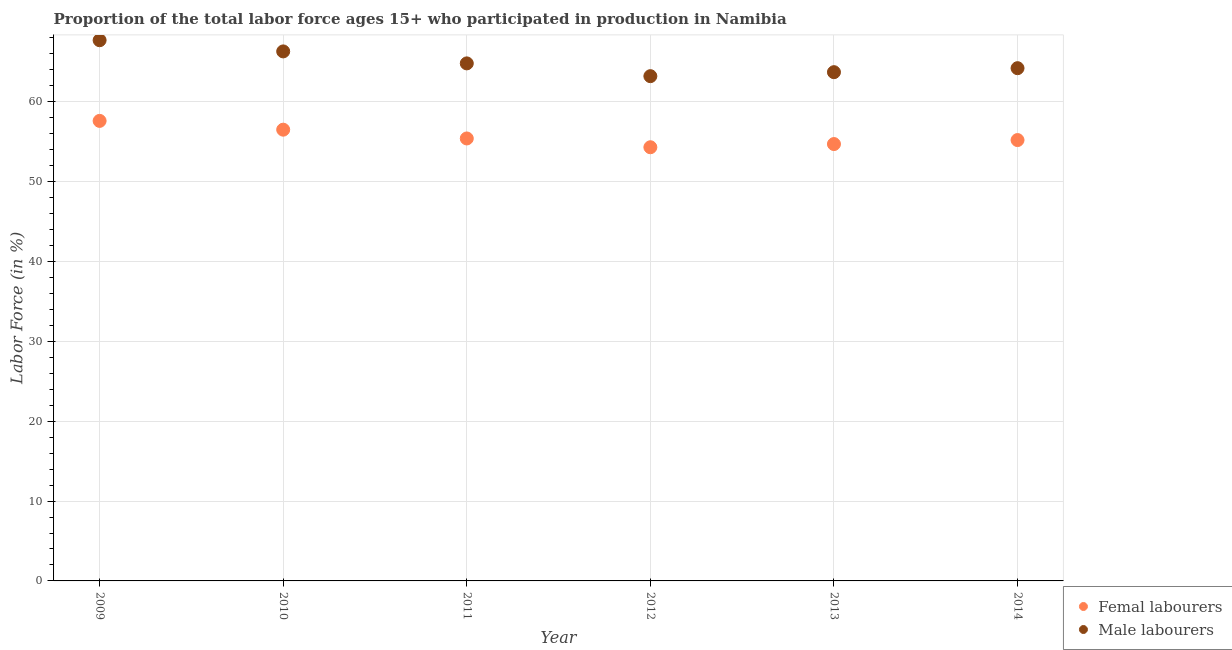How many different coloured dotlines are there?
Offer a terse response. 2. Is the number of dotlines equal to the number of legend labels?
Provide a succinct answer. Yes. What is the percentage of male labour force in 2011?
Keep it short and to the point. 64.8. Across all years, what is the maximum percentage of male labour force?
Your response must be concise. 67.7. Across all years, what is the minimum percentage of male labour force?
Provide a succinct answer. 63.2. In which year was the percentage of female labor force maximum?
Provide a short and direct response. 2009. What is the total percentage of female labor force in the graph?
Keep it short and to the point. 333.7. What is the difference between the percentage of female labor force in 2009 and that in 2013?
Ensure brevity in your answer.  2.9. What is the difference between the percentage of male labour force in 2013 and the percentage of female labor force in 2012?
Your response must be concise. 9.4. What is the average percentage of male labour force per year?
Provide a short and direct response. 64.98. In the year 2011, what is the difference between the percentage of female labor force and percentage of male labour force?
Your response must be concise. -9.4. What is the ratio of the percentage of male labour force in 2009 to that in 2013?
Keep it short and to the point. 1.06. What is the difference between the highest and the second highest percentage of male labour force?
Provide a short and direct response. 1.4. What is the difference between the highest and the lowest percentage of female labor force?
Your answer should be compact. 3.3. In how many years, is the percentage of female labor force greater than the average percentage of female labor force taken over all years?
Your answer should be compact. 2. Is the percentage of female labor force strictly greater than the percentage of male labour force over the years?
Give a very brief answer. No. How many dotlines are there?
Keep it short and to the point. 2. How many years are there in the graph?
Your response must be concise. 6. What is the difference between two consecutive major ticks on the Y-axis?
Give a very brief answer. 10. Are the values on the major ticks of Y-axis written in scientific E-notation?
Provide a succinct answer. No. Where does the legend appear in the graph?
Give a very brief answer. Bottom right. How many legend labels are there?
Make the answer very short. 2. How are the legend labels stacked?
Your answer should be compact. Vertical. What is the title of the graph?
Your response must be concise. Proportion of the total labor force ages 15+ who participated in production in Namibia. What is the Labor Force (in %) of Femal labourers in 2009?
Your answer should be compact. 57.6. What is the Labor Force (in %) in Male labourers in 2009?
Provide a short and direct response. 67.7. What is the Labor Force (in %) in Femal labourers in 2010?
Make the answer very short. 56.5. What is the Labor Force (in %) in Male labourers in 2010?
Your answer should be compact. 66.3. What is the Labor Force (in %) of Femal labourers in 2011?
Provide a succinct answer. 55.4. What is the Labor Force (in %) in Male labourers in 2011?
Provide a short and direct response. 64.8. What is the Labor Force (in %) of Femal labourers in 2012?
Provide a short and direct response. 54.3. What is the Labor Force (in %) of Male labourers in 2012?
Keep it short and to the point. 63.2. What is the Labor Force (in %) in Femal labourers in 2013?
Your response must be concise. 54.7. What is the Labor Force (in %) in Male labourers in 2013?
Make the answer very short. 63.7. What is the Labor Force (in %) of Femal labourers in 2014?
Give a very brief answer. 55.2. What is the Labor Force (in %) in Male labourers in 2014?
Give a very brief answer. 64.2. Across all years, what is the maximum Labor Force (in %) in Femal labourers?
Your answer should be compact. 57.6. Across all years, what is the maximum Labor Force (in %) in Male labourers?
Offer a very short reply. 67.7. Across all years, what is the minimum Labor Force (in %) in Femal labourers?
Ensure brevity in your answer.  54.3. Across all years, what is the minimum Labor Force (in %) of Male labourers?
Ensure brevity in your answer.  63.2. What is the total Labor Force (in %) in Femal labourers in the graph?
Offer a very short reply. 333.7. What is the total Labor Force (in %) of Male labourers in the graph?
Offer a very short reply. 389.9. What is the difference between the Labor Force (in %) of Femal labourers in 2009 and that in 2010?
Keep it short and to the point. 1.1. What is the difference between the Labor Force (in %) in Male labourers in 2009 and that in 2010?
Your answer should be compact. 1.4. What is the difference between the Labor Force (in %) in Femal labourers in 2009 and that in 2011?
Your answer should be very brief. 2.2. What is the difference between the Labor Force (in %) in Male labourers in 2009 and that in 2011?
Offer a very short reply. 2.9. What is the difference between the Labor Force (in %) of Femal labourers in 2009 and that in 2012?
Your response must be concise. 3.3. What is the difference between the Labor Force (in %) of Male labourers in 2009 and that in 2013?
Provide a succinct answer. 4. What is the difference between the Labor Force (in %) in Femal labourers in 2010 and that in 2011?
Offer a terse response. 1.1. What is the difference between the Labor Force (in %) in Male labourers in 2010 and that in 2011?
Your response must be concise. 1.5. What is the difference between the Labor Force (in %) in Femal labourers in 2010 and that in 2012?
Give a very brief answer. 2.2. What is the difference between the Labor Force (in %) of Femal labourers in 2010 and that in 2013?
Provide a succinct answer. 1.8. What is the difference between the Labor Force (in %) in Male labourers in 2010 and that in 2013?
Offer a very short reply. 2.6. What is the difference between the Labor Force (in %) in Male labourers in 2010 and that in 2014?
Give a very brief answer. 2.1. What is the difference between the Labor Force (in %) in Femal labourers in 2011 and that in 2012?
Ensure brevity in your answer.  1.1. What is the difference between the Labor Force (in %) of Male labourers in 2012 and that in 2013?
Your answer should be compact. -0.5. What is the difference between the Labor Force (in %) of Male labourers in 2012 and that in 2014?
Provide a short and direct response. -1. What is the difference between the Labor Force (in %) of Male labourers in 2013 and that in 2014?
Offer a terse response. -0.5. What is the difference between the Labor Force (in %) of Femal labourers in 2009 and the Labor Force (in %) of Male labourers in 2011?
Keep it short and to the point. -7.2. What is the difference between the Labor Force (in %) of Femal labourers in 2010 and the Labor Force (in %) of Male labourers in 2011?
Make the answer very short. -8.3. What is the difference between the Labor Force (in %) of Femal labourers in 2010 and the Labor Force (in %) of Male labourers in 2012?
Provide a short and direct response. -6.7. What is the difference between the Labor Force (in %) of Femal labourers in 2010 and the Labor Force (in %) of Male labourers in 2013?
Provide a short and direct response. -7.2. What is the difference between the Labor Force (in %) of Femal labourers in 2010 and the Labor Force (in %) of Male labourers in 2014?
Your response must be concise. -7.7. What is the difference between the Labor Force (in %) in Femal labourers in 2011 and the Labor Force (in %) in Male labourers in 2013?
Provide a succinct answer. -8.3. What is the difference between the Labor Force (in %) in Femal labourers in 2012 and the Labor Force (in %) in Male labourers in 2013?
Offer a terse response. -9.4. What is the average Labor Force (in %) in Femal labourers per year?
Your response must be concise. 55.62. What is the average Labor Force (in %) in Male labourers per year?
Ensure brevity in your answer.  64.98. In the year 2009, what is the difference between the Labor Force (in %) of Femal labourers and Labor Force (in %) of Male labourers?
Provide a succinct answer. -10.1. In the year 2010, what is the difference between the Labor Force (in %) of Femal labourers and Labor Force (in %) of Male labourers?
Your answer should be compact. -9.8. In the year 2011, what is the difference between the Labor Force (in %) of Femal labourers and Labor Force (in %) of Male labourers?
Your answer should be compact. -9.4. In the year 2012, what is the difference between the Labor Force (in %) of Femal labourers and Labor Force (in %) of Male labourers?
Provide a succinct answer. -8.9. In the year 2014, what is the difference between the Labor Force (in %) in Femal labourers and Labor Force (in %) in Male labourers?
Your answer should be very brief. -9. What is the ratio of the Labor Force (in %) in Femal labourers in 2009 to that in 2010?
Your response must be concise. 1.02. What is the ratio of the Labor Force (in %) in Male labourers in 2009 to that in 2010?
Offer a very short reply. 1.02. What is the ratio of the Labor Force (in %) of Femal labourers in 2009 to that in 2011?
Provide a succinct answer. 1.04. What is the ratio of the Labor Force (in %) in Male labourers in 2009 to that in 2011?
Your answer should be compact. 1.04. What is the ratio of the Labor Force (in %) of Femal labourers in 2009 to that in 2012?
Provide a short and direct response. 1.06. What is the ratio of the Labor Force (in %) of Male labourers in 2009 to that in 2012?
Keep it short and to the point. 1.07. What is the ratio of the Labor Force (in %) in Femal labourers in 2009 to that in 2013?
Keep it short and to the point. 1.05. What is the ratio of the Labor Force (in %) of Male labourers in 2009 to that in 2013?
Your answer should be compact. 1.06. What is the ratio of the Labor Force (in %) in Femal labourers in 2009 to that in 2014?
Ensure brevity in your answer.  1.04. What is the ratio of the Labor Force (in %) of Male labourers in 2009 to that in 2014?
Give a very brief answer. 1.05. What is the ratio of the Labor Force (in %) of Femal labourers in 2010 to that in 2011?
Keep it short and to the point. 1.02. What is the ratio of the Labor Force (in %) in Male labourers in 2010 to that in 2011?
Your answer should be compact. 1.02. What is the ratio of the Labor Force (in %) of Femal labourers in 2010 to that in 2012?
Give a very brief answer. 1.04. What is the ratio of the Labor Force (in %) of Male labourers in 2010 to that in 2012?
Your response must be concise. 1.05. What is the ratio of the Labor Force (in %) of Femal labourers in 2010 to that in 2013?
Provide a short and direct response. 1.03. What is the ratio of the Labor Force (in %) in Male labourers in 2010 to that in 2013?
Make the answer very short. 1.04. What is the ratio of the Labor Force (in %) of Femal labourers in 2010 to that in 2014?
Provide a short and direct response. 1.02. What is the ratio of the Labor Force (in %) in Male labourers in 2010 to that in 2014?
Offer a terse response. 1.03. What is the ratio of the Labor Force (in %) of Femal labourers in 2011 to that in 2012?
Keep it short and to the point. 1.02. What is the ratio of the Labor Force (in %) of Male labourers in 2011 to that in 2012?
Your answer should be compact. 1.03. What is the ratio of the Labor Force (in %) in Femal labourers in 2011 to that in 2013?
Your answer should be very brief. 1.01. What is the ratio of the Labor Force (in %) in Male labourers in 2011 to that in 2013?
Give a very brief answer. 1.02. What is the ratio of the Labor Force (in %) in Male labourers in 2011 to that in 2014?
Provide a succinct answer. 1.01. What is the ratio of the Labor Force (in %) of Femal labourers in 2012 to that in 2014?
Give a very brief answer. 0.98. What is the ratio of the Labor Force (in %) in Male labourers in 2012 to that in 2014?
Provide a short and direct response. 0.98. What is the ratio of the Labor Force (in %) in Femal labourers in 2013 to that in 2014?
Provide a succinct answer. 0.99. What is the ratio of the Labor Force (in %) in Male labourers in 2013 to that in 2014?
Make the answer very short. 0.99. What is the difference between the highest and the second highest Labor Force (in %) of Femal labourers?
Your answer should be very brief. 1.1. What is the difference between the highest and the lowest Labor Force (in %) in Femal labourers?
Ensure brevity in your answer.  3.3. 